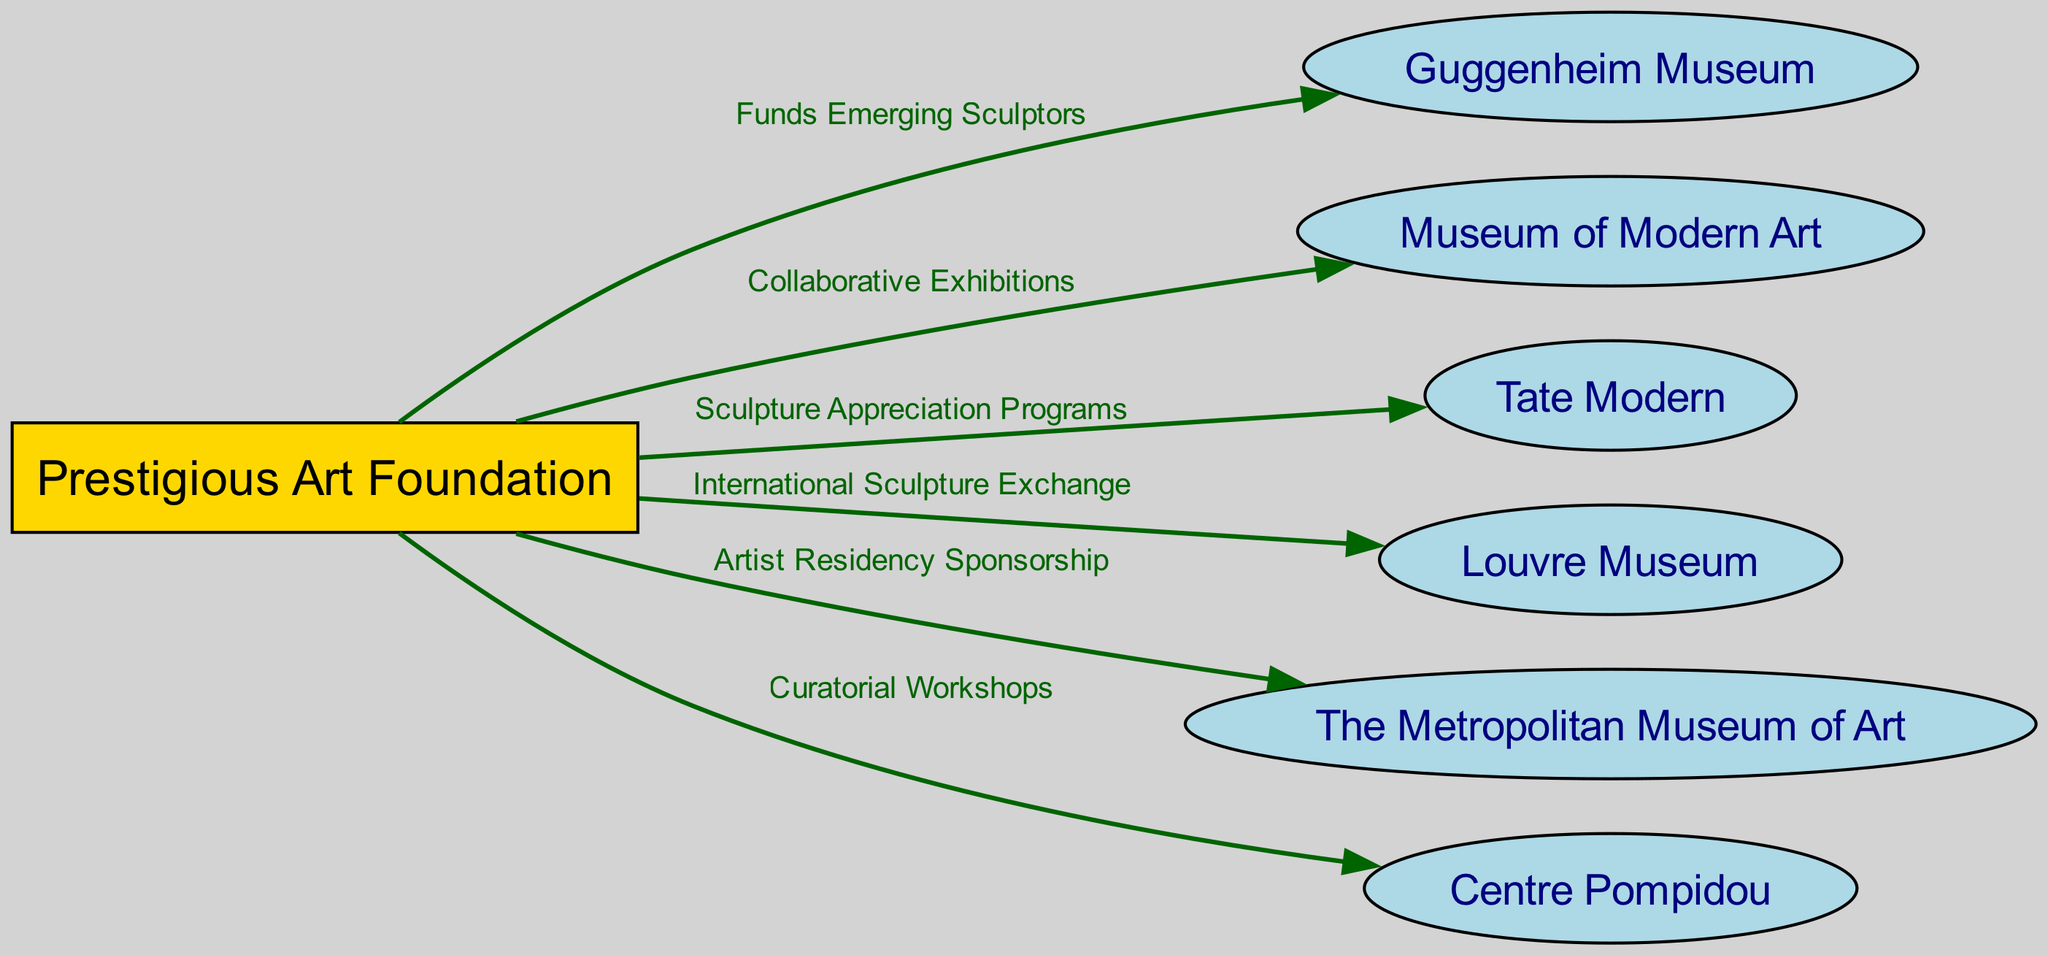What is the total number of nodes in the diagram? The diagram consists of seven nodes: the Prestigious Art Foundation and six art institutions including the Guggenheim Museum, Museum of Modern Art, Tate Modern, Louvre Museum, The Metropolitan Museum of Art, and Centre Pompidou. Thus, the total number of nodes is seven.
Answer: 7 What is the relationship between the Foundation and the Tate? According to the diagram, the relationship is represented by "Sculpture Appreciation Programs," which connects the Foundation to Tate Modern. This indicates that the Foundation has programs specifically focused on appreciating sculpture that collaborates with Tate.
Answer: Sculpture Appreciation Programs Which museum is linked to the Foundation through an International Sculpture Exchange? The Louvre Museum is connected to the Foundation with the specific relationship defined as "International Sculpture Exchange," demonstrating a collaboration in this particular area.
Answer: Louvre Museum How many edges connect the Foundation to other institutions? The diagram shows five edges, each representing a different connection from the Foundation to the various museums and galleries, indicating distinct collaborative relationships.
Answer: 5 What type of workshops does the Foundation organize with the Centre Pompidou? The diagram indicates that the Foundation organizes "Curatorial Workshops" in collaboration with the Centre Pompidou, signaling a focus on curatorial practices.
Answer: Curatorial Workshops Which institution is associated with artist residency sponsorship? The Metropolitan Museum of Art is the institution linked to artist residency sponsorship as per the edge labeled "Artist Residency Sponsorship," highlighting its role in supporting artists through residency programs.
Answer: The Metropolitan Museum of Art What color represents the Foundation in the diagram? The Foundation is represented in gold, as indicated by its rectangle shape and filled color in the visual diagram, indicating its prestigious nature compared to the other institutions.
Answer: Gold Which art institution is connected to the Foundation for collaborative exhibitions? The Museum of Modern Art is the institution associated with the Foundation for "Collaborative Exhibitions," which highlights a partnership focused on showcasing art together.
Answer: Museum of Modern Art How many total relationships are depicted in the diagram? The diagram outlines six relationships (edges) linking the Foundation to other art institutions, each showcasing a different area of collaboration or support.
Answer: 6 